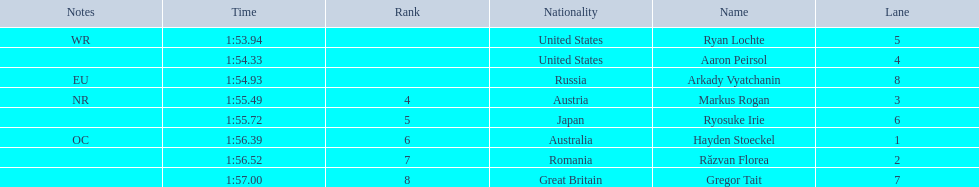Does russia or japan have the longer time? Japan. 